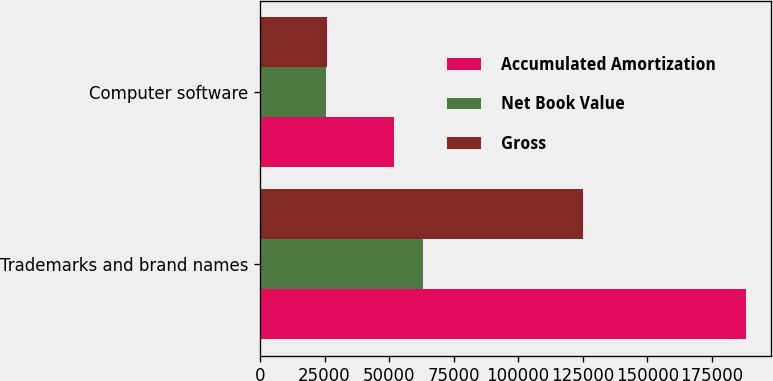<chart> <loc_0><loc_0><loc_500><loc_500><stacked_bar_chart><ecel><fcel>Trademarks and brand names<fcel>Computer software<nl><fcel>Accumulated Amortization<fcel>188300<fcel>51893<nl><fcel>Net Book Value<fcel>63157<fcel>25770<nl><fcel>Gross<fcel>125143<fcel>26123<nl></chart> 